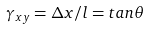<formula> <loc_0><loc_0><loc_500><loc_500>\gamma _ { x y } = \Delta x / l = t a n \theta</formula> 